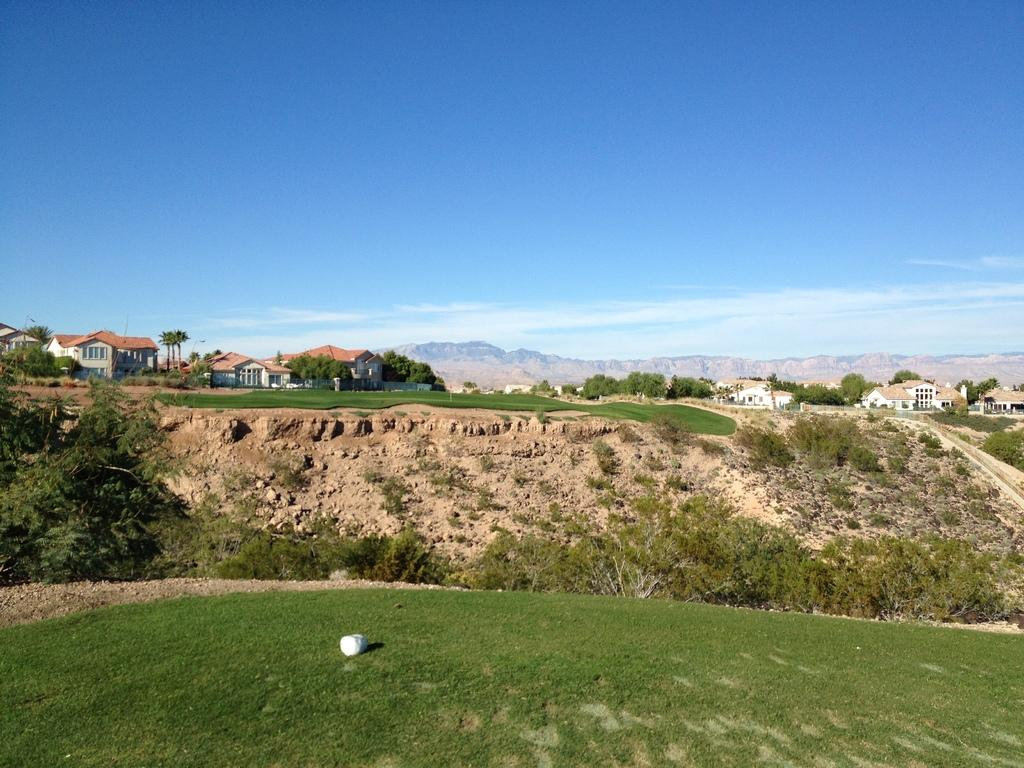What type of vegetation is on the ground in the image? There is grass on the ground in the image. What other natural elements can be seen in the image? There are trees in the image. What can be seen in the background of the image? There are buildings, more trees, hills, and the sky visible in the background of the image. What is the condition of the sky in the image? Clouds are present in the sky. What type of grass is the voice using to communicate in the image? There is no voice or communication present in the image, and grass does not have the ability to communicate. What type of apparatus is being used to measure the height of the trees in the image? There is no apparatus visible in the image for measuring the height of the trees. 